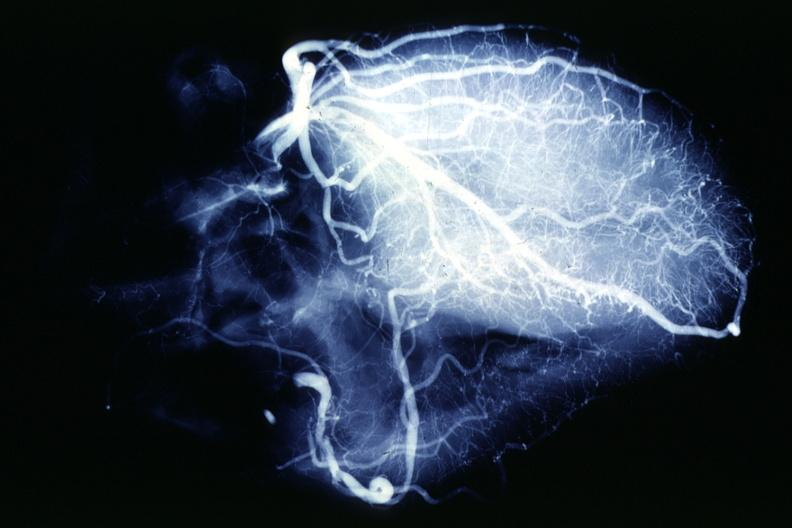s liver present?
Answer the question using a single word or phrase. No 